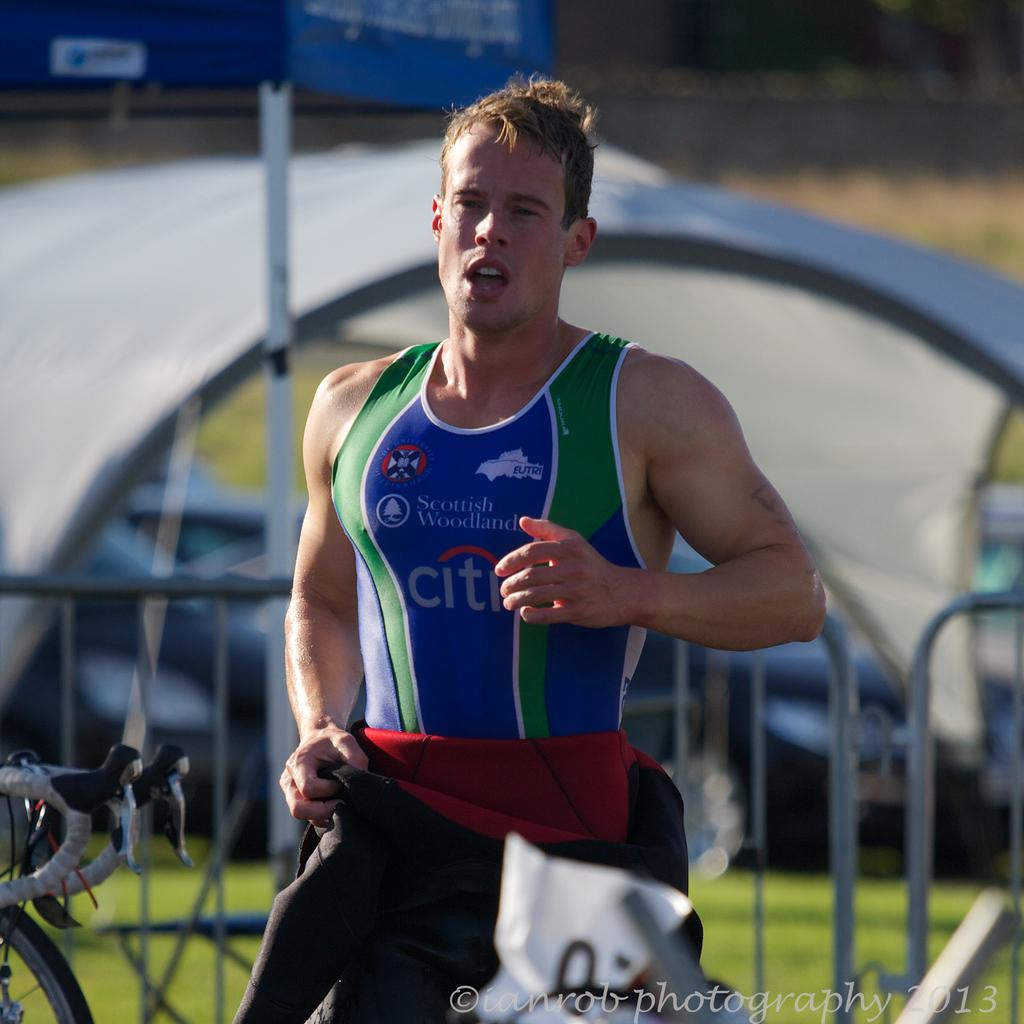<image>
Describe the image concisely. The runner is sponsored by Scottish Woodlands and Citibank. 